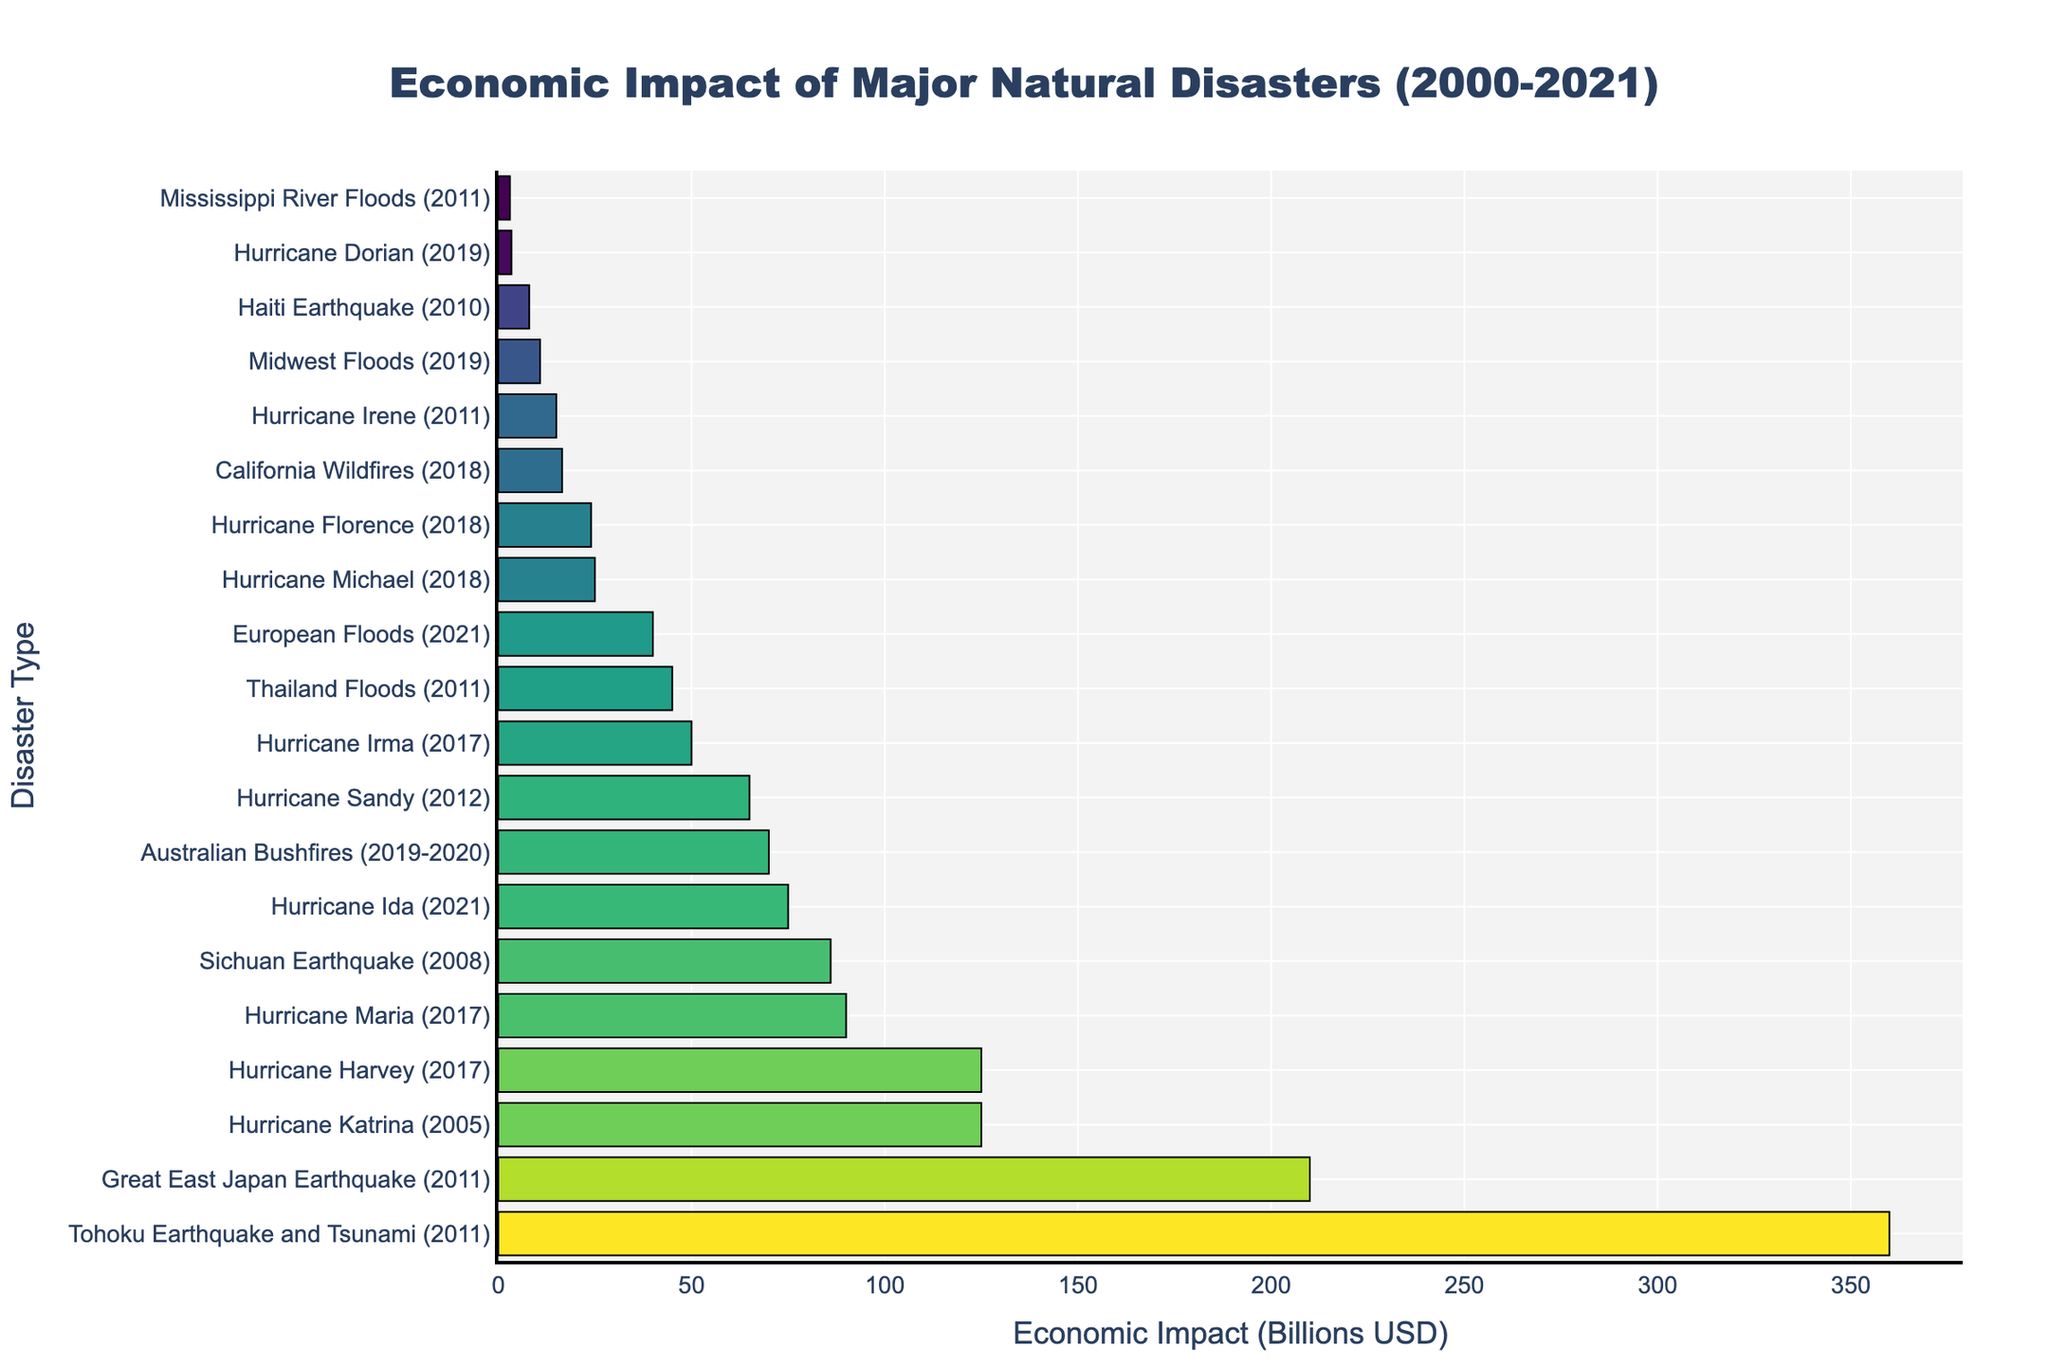What is the economic impact of the Tohoku Earthquake and Tsunami in 2011? The bar representing the Tohoku Earthquake and Tsunami shows an economic impact of 360 billion USD.
Answer: 360 billion USD Which disaster had the least economic impact? Observing the bars, the Mississippi River Floods (2011) had the smallest economic impact with a value of 3 billion USD.
Answer: Mississippi River Floods How does the economic impact of Hurricane Maria compare to Hurricane Katrina? Comparing the lengths of their bars, Hurricane Maria has an economic impact of 90 billion USD, whereas Hurricane Katrina has an impact of 125 billion USD.
Answer: Hurricane Katrina's impact is greater than Hurricane Maria's What is the combined economic impact of all the hurricanes listed (2005-2021)? Summing the impacts of all hurricanes: 125 (Katrina) + 125 (Harvey) + 90 (Maria) + 50 (Irma) + 75 (Ida) + 65 (Sandy) + 15 (Irene) + 25 (Michael) + 24 (Florence) + 3.4 (Dorian) = 592.4 billion USD.
Answer: 592.4 billion USD Which year had the highest recorded economic impact from natural disasters? Observing the grouped bars for each year, 2011 stands out with multiple major disasters including the Tohoku Earthquake and Tsunami (360 billion USD) and the Great East Japan Earthquake (210 billion USD).
Answer: 2011 What is the difference in economic impact between the Great East Japan Earthquake (2011) and the Sichuan Earthquake (2008)? The impact of the Great East Japan Earthquake is 210 billion USD, and the Sichuan Earthquake is 86 billion USD. The difference is 210 - 86 = 124 billion USD.
Answer: 124 billion USD Among the disasters listed with impacts below 50 billion USD, which one has the highest impact? The Thai Floods (2011) have an economic impact of 45 billion USD which is the highest among those below 50 billion USD.
Answer: Thailand Floods (2011) How do the economic impacts of the California Wildfires (2018) and the Australian Bushfires (2019-2020) compare? The California Wildfires have an impact of 16.5 billion USD while the Australian Bushfires have 70 billion USD. The bar lengths indicate that the Australian Bushfires caused a significantly higher economic impact.
Answer: Australian Bushfires' impact is greater than California Wildfires Which disaster had a higher impact: the European Floods (2021) or Hurricane Sandy (2012)? By comparing the bars, Hurricane Sandy's impact is 65 billion USD, whereas the European Floods had an impact of 40 billion USD.
Answer: Hurricane Sandy's impact is higher 